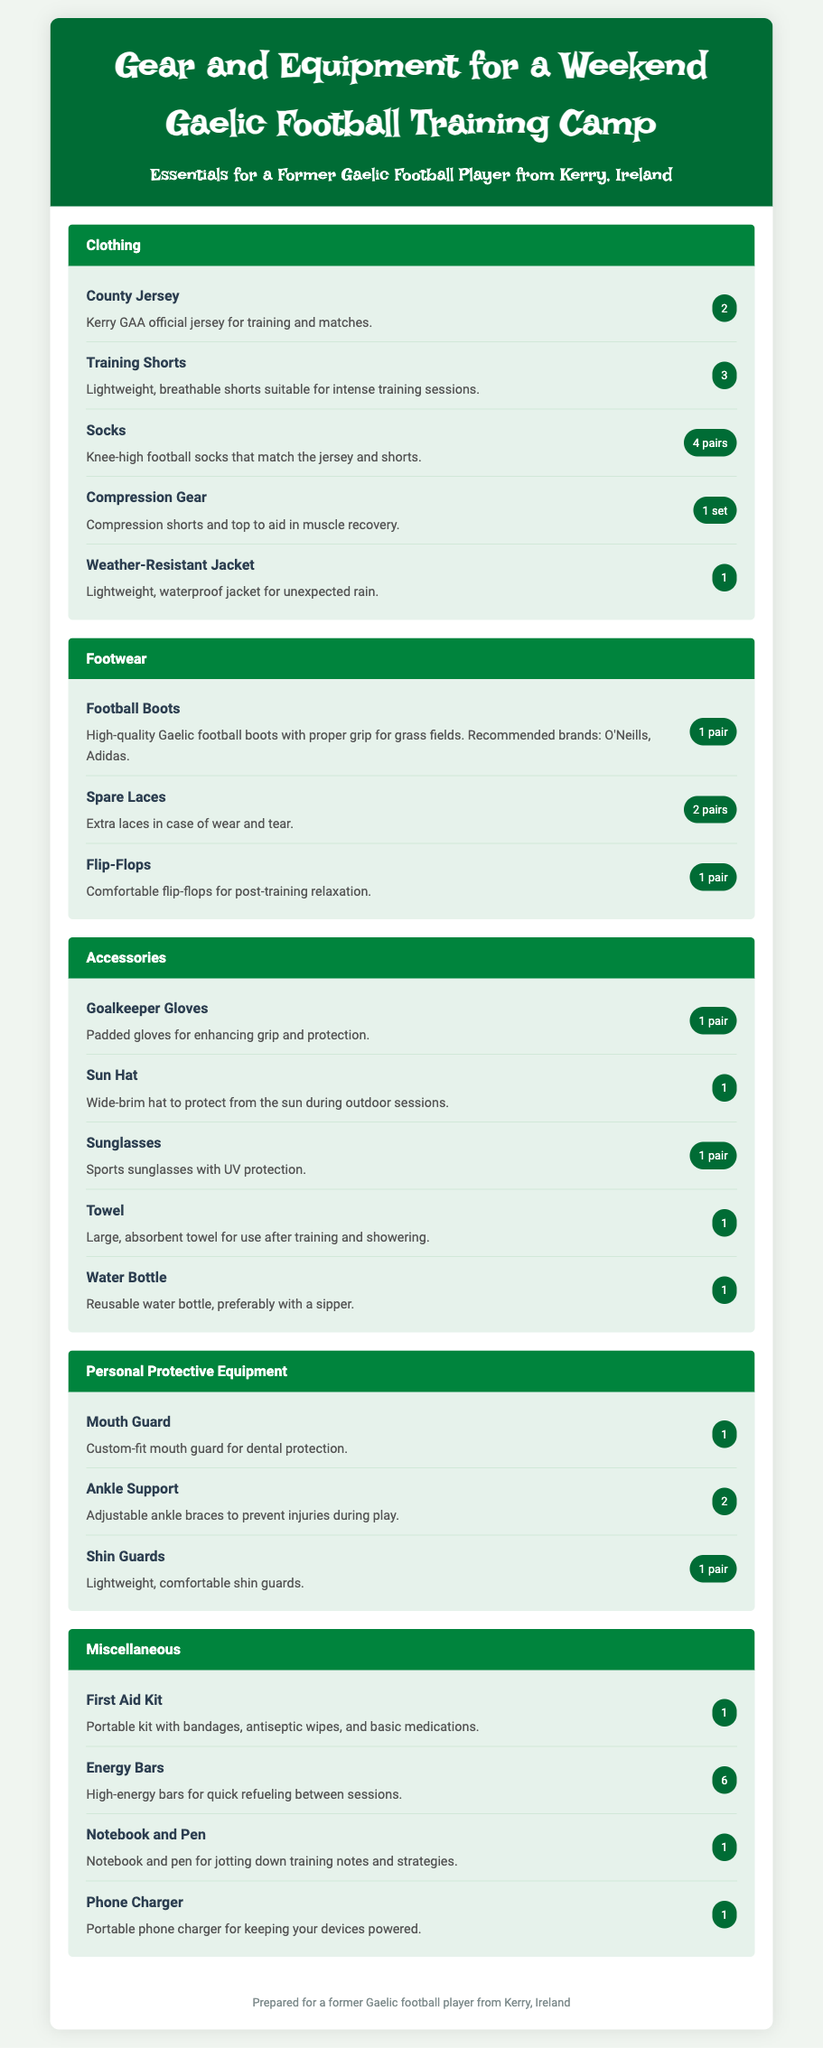What is the number of County Jerseys recommended? The document states that 2 County Jerseys are recommended for training and matches.
Answer: 2 How many pairs of socks are listed? The document specifies that 4 pairs of socks are included in the packing list.
Answer: 4 pairs What item is mentioned for dental protection? The document includes a mouth guard for dental protection.
Answer: Mouth Guard Which footwear is recommended for grass fields? The document recommends high-quality Gaelic football boots for proper grip on grass fields.
Answer: Football Boots What is the quantity of energy bars suggested? The packing list suggests bringing 6 energy bars for quick refueling.
Answer: 6 How many items are listed under Personal Protective Equipment? The document includes 3 items listed under Personal Protective Equipment.
Answer: 3 What is recommended for post-training relaxation? The document suggests bringing comfortable flip-flops for post-training relaxation.
Answer: Flip-Flops What type of jacket is included in the packing list? The packing list includes a weather-resistant jacket for unexpected rain.
Answer: Weather-Resistant Jacket 